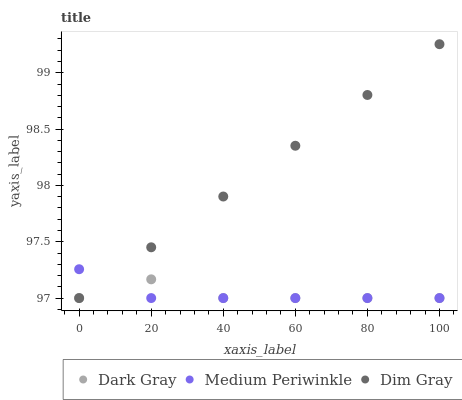Does Medium Periwinkle have the minimum area under the curve?
Answer yes or no. Yes. Does Dim Gray have the maximum area under the curve?
Answer yes or no. Yes. Does Dim Gray have the minimum area under the curve?
Answer yes or no. No. Does Medium Periwinkle have the maximum area under the curve?
Answer yes or no. No. Is Dim Gray the smoothest?
Answer yes or no. Yes. Is Dark Gray the roughest?
Answer yes or no. Yes. Is Medium Periwinkle the smoothest?
Answer yes or no. No. Is Medium Periwinkle the roughest?
Answer yes or no. No. Does Dark Gray have the lowest value?
Answer yes or no. Yes. Does Dim Gray have the highest value?
Answer yes or no. Yes. Does Medium Periwinkle have the highest value?
Answer yes or no. No. Does Dim Gray intersect Medium Periwinkle?
Answer yes or no. Yes. Is Dim Gray less than Medium Periwinkle?
Answer yes or no. No. Is Dim Gray greater than Medium Periwinkle?
Answer yes or no. No. 